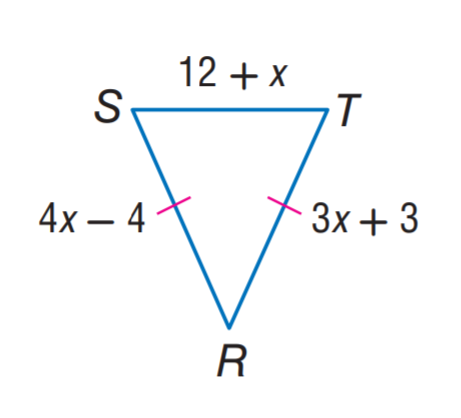Answer the mathemtical geometry problem and directly provide the correct option letter.
Question: Find R T.
Choices: A: 12 B: 24 C: 27 D: 28 B 